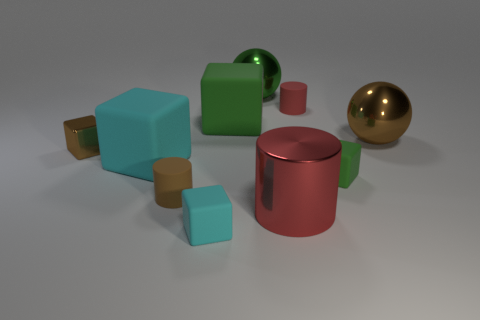Subtract all metallic cylinders. How many cylinders are left? 2 Subtract all brown cylinders. How many cylinders are left? 2 Subtract 2 blocks. How many blocks are left? 3 Subtract 0 red blocks. How many objects are left? 10 Subtract all cylinders. How many objects are left? 7 Subtract all brown cylinders. Subtract all gray cubes. How many cylinders are left? 2 Subtract all gray cubes. How many red cylinders are left? 2 Subtract all cyan cubes. Subtract all tiny rubber cubes. How many objects are left? 6 Add 8 large spheres. How many large spheres are left? 10 Add 4 brown blocks. How many brown blocks exist? 5 